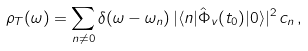Convert formula to latex. <formula><loc_0><loc_0><loc_500><loc_500>\rho _ { T } ( \omega ) = \sum _ { n \neq 0 } \delta ( \omega - \omega _ { n } ) \, | \langle n | \hat { \Phi } _ { v } ( t _ { 0 } ) | 0 \rangle | ^ { 2 } \, c _ { n } \, ,</formula> 